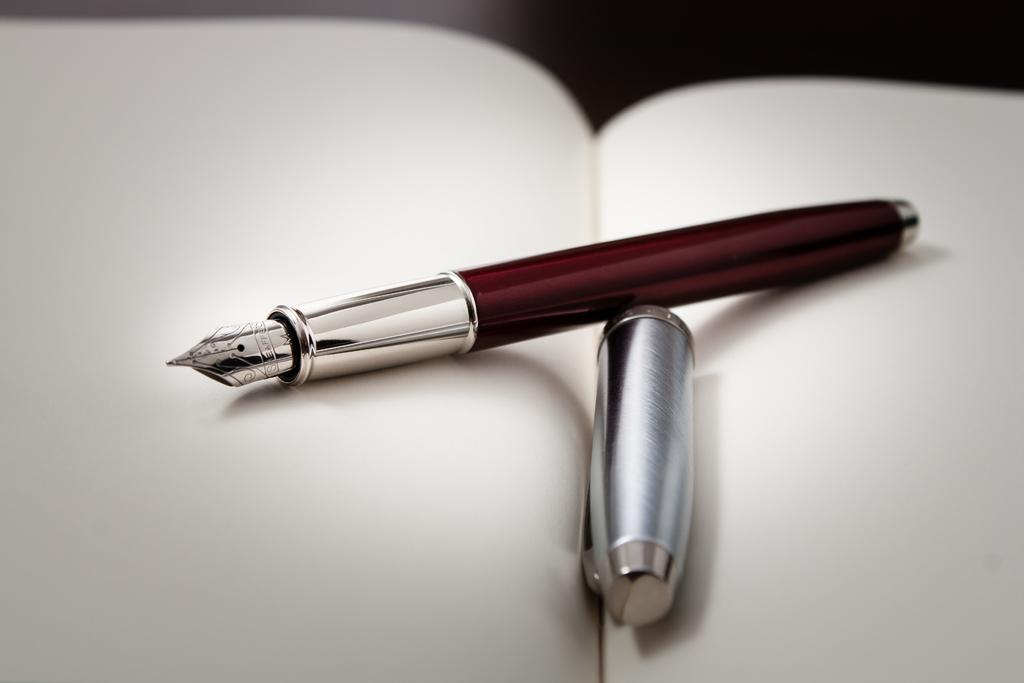What object is visible in the image? There is a pen in the image. Where is the pen located? The pen is placed on a book. Can you describe the background of the image? The background of the image is blurred. What type of war is depicted in the image? There is no war depicted in the image; it features a pen placed on a book with a blurred background. 